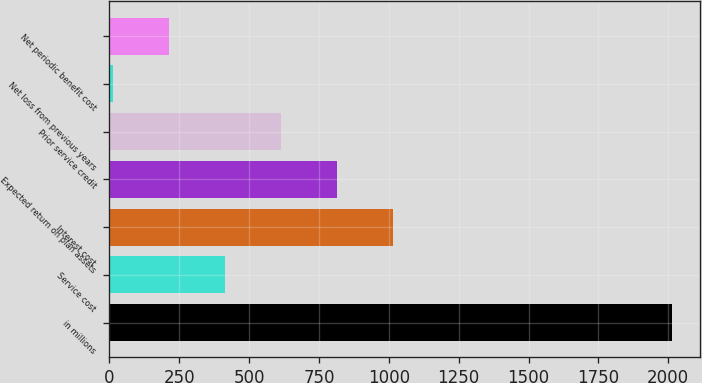Convert chart. <chart><loc_0><loc_0><loc_500><loc_500><bar_chart><fcel>in millions<fcel>Service cost<fcel>Interest cost<fcel>Expected return on plan assets<fcel>Prior service credit<fcel>Net loss from previous years<fcel>Net periodic benefit cost<nl><fcel>2014<fcel>413.2<fcel>1013.5<fcel>813.4<fcel>613.3<fcel>13<fcel>213.1<nl></chart> 